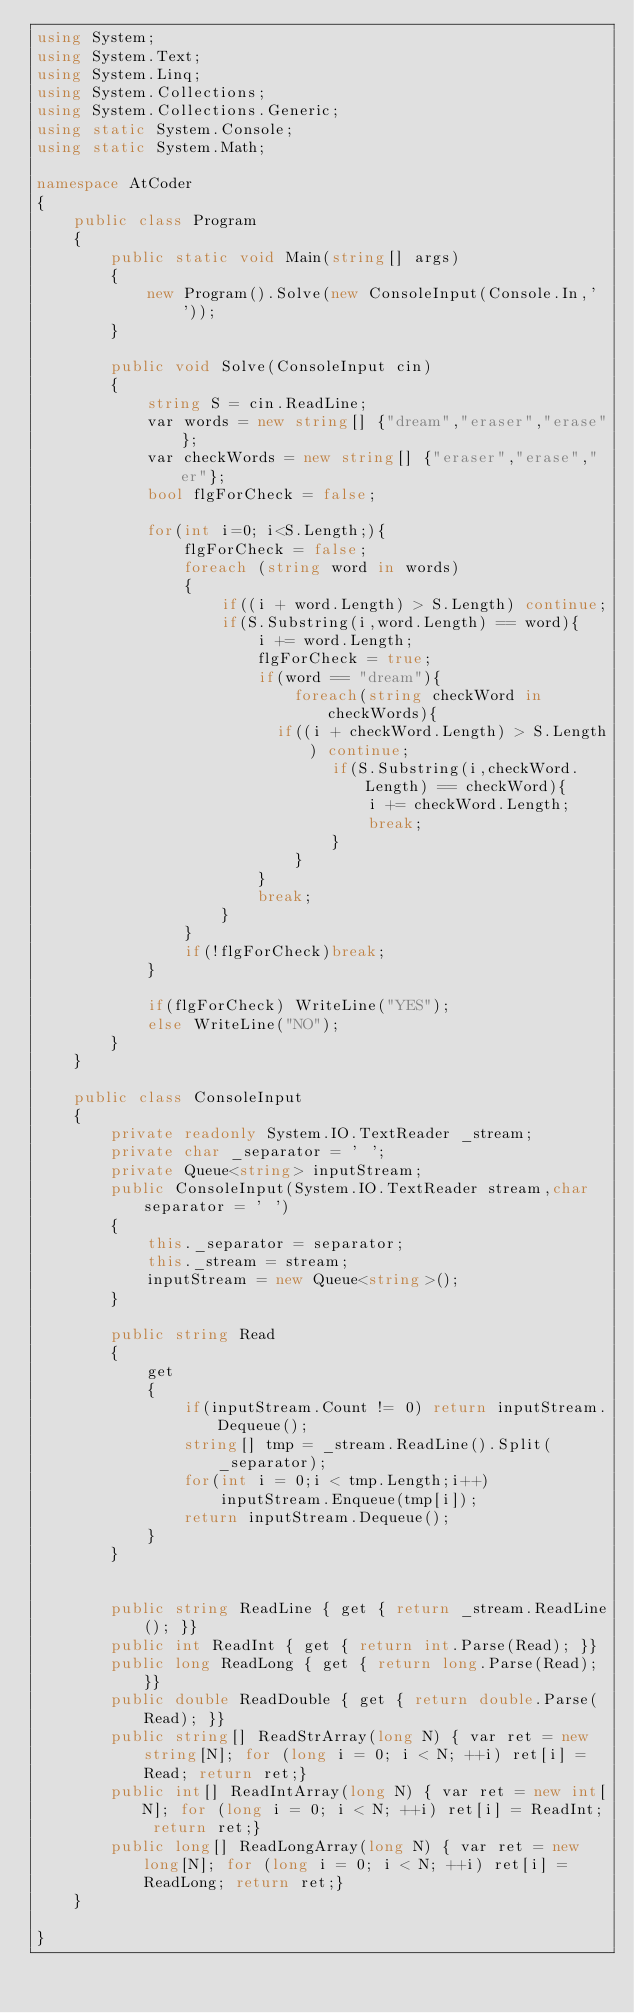Convert code to text. <code><loc_0><loc_0><loc_500><loc_500><_C#_>using System;
using System.Text;
using System.Linq;
using System.Collections;
using System.Collections.Generic;
using static System.Console;
using static System.Math;

namespace AtCoder
{
    public class Program
    {
        public static void Main(string[] args)
        {
            new Program().Solve(new ConsoleInput(Console.In,' '));
        }

        public void Solve(ConsoleInput cin)
        {
            string S = cin.ReadLine;
            var words = new string[] {"dream","eraser","erase"};
            var checkWords = new string[] {"eraser","erase","er"};
            bool flgForCheck = false;

            for(int i=0; i<S.Length;){
              	flgForCheck = false;
                foreach (string word in words)
                {
                  	if((i + word.Length) > S.Length) continue;
                    if(S.Substring(i,word.Length) == word){
                        i += word.Length;
                        flgForCheck = true;
                        if(word == "dream"){
                            foreach(string checkWord in checkWords){
                  				if((i + checkWord.Length) > S.Length) continue;
                                if(S.Substring(i,checkWord.Length) == checkWord){
                                    i += checkWord.Length;
                                  	break;
                                }
                            }
                        }
                        break;
                    }
                }
                if(!flgForCheck)break;
            }

            if(flgForCheck) WriteLine("YES");
            else WriteLine("NO");
        }
    }

    public class ConsoleInput
    {
        private readonly System.IO.TextReader _stream;
        private char _separator = ' ';
        private Queue<string> inputStream;
        public ConsoleInput(System.IO.TextReader stream,char separator = ' ')
        {
            this._separator = separator;
            this._stream = stream;
            inputStream = new Queue<string>();
        }

        public string Read
        {
            get
            {
                if(inputStream.Count != 0) return inputStream.Dequeue();
                string[] tmp = _stream.ReadLine().Split(_separator);
                for(int i = 0;i < tmp.Length;i++)
                    inputStream.Enqueue(tmp[i]);
                return inputStream.Dequeue();
            }
        }

        
        public string ReadLine { get { return _stream.ReadLine(); }}
        public int ReadInt { get { return int.Parse(Read); }}
        public long ReadLong { get { return long.Parse(Read); }}
        public double ReadDouble { get { return double.Parse(Read); }}
        public string[] ReadStrArray(long N) { var ret = new string[N]; for (long i = 0; i < N; ++i) ret[i] = Read; return ret;}
        public int[] ReadIntArray(long N) { var ret = new int[N]; for (long i = 0; i < N; ++i) ret[i] = ReadInt; return ret;}
        public long[] ReadLongArray(long N) { var ret = new long[N]; for (long i = 0; i < N; ++i) ret[i] = ReadLong; return ret;}
    }

}</code> 